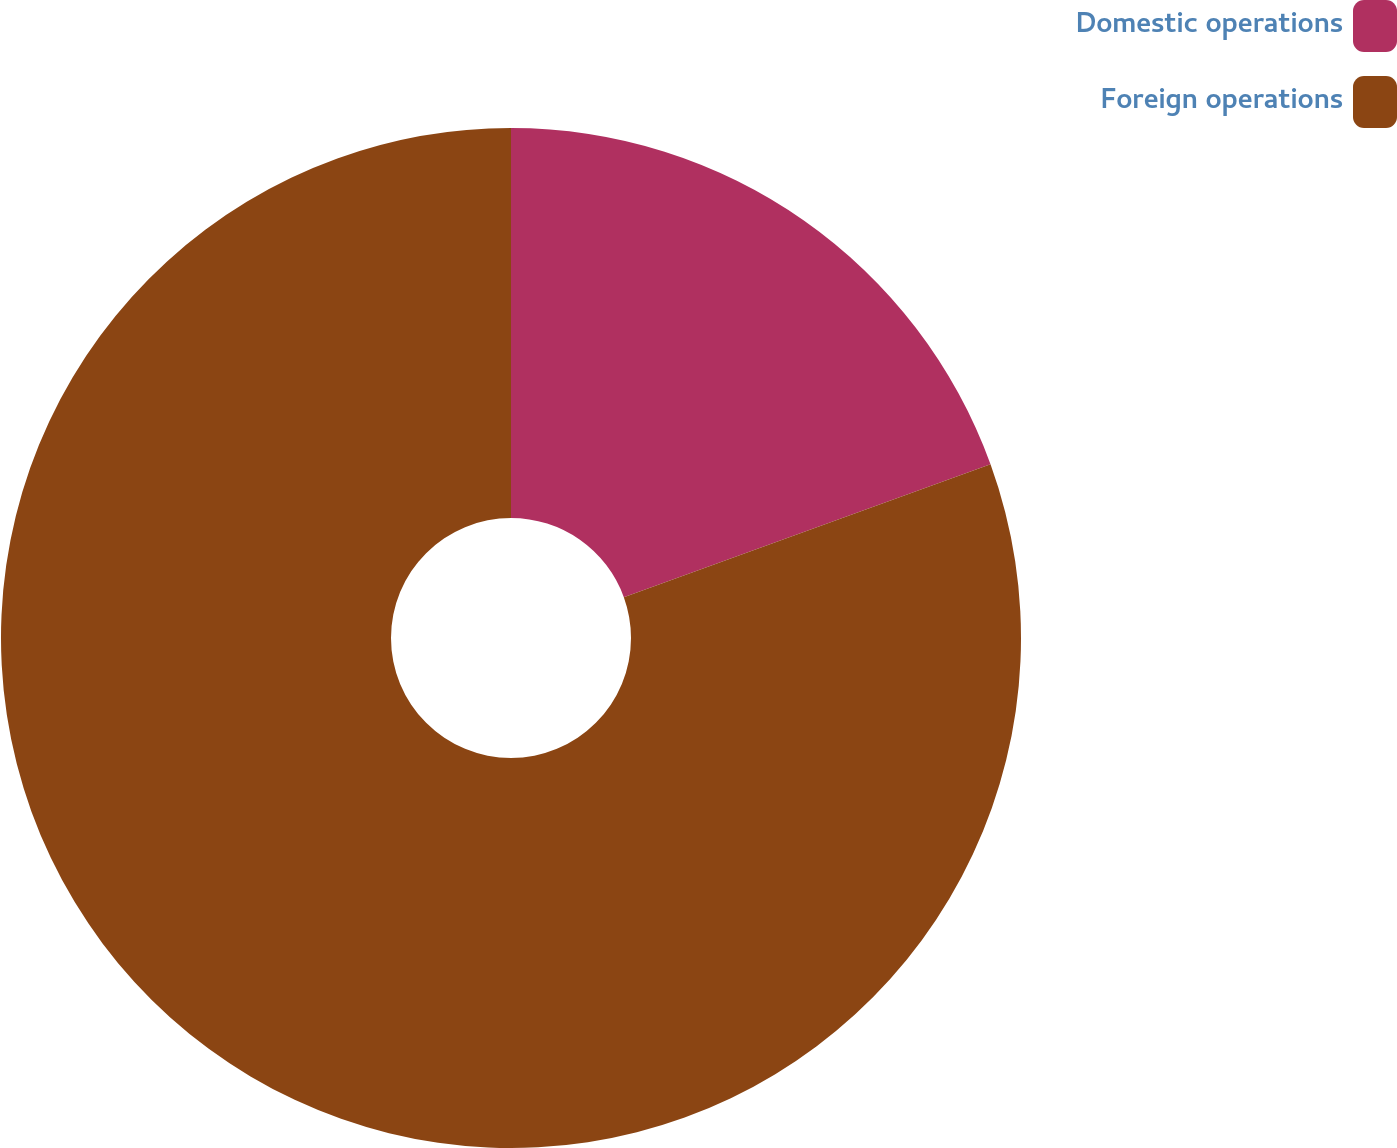<chart> <loc_0><loc_0><loc_500><loc_500><pie_chart><fcel>Domestic operations<fcel>Foreign operations<nl><fcel>19.47%<fcel>80.53%<nl></chart> 